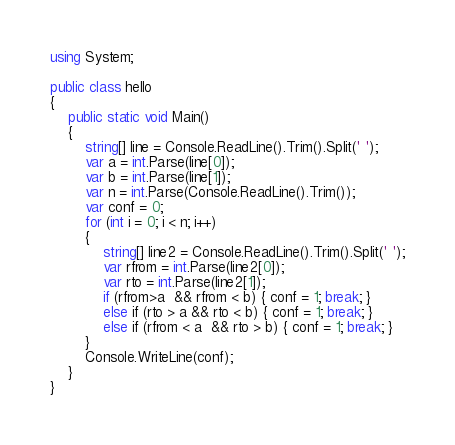<code> <loc_0><loc_0><loc_500><loc_500><_C#_>using System;

public class hello
{
    public static void Main()
    {
        string[] line = Console.ReadLine().Trim().Split(' ');
        var a = int.Parse(line[0]);
        var b = int.Parse(line[1]);
        var n = int.Parse(Console.ReadLine().Trim());
        var conf = 0;
        for (int i = 0; i < n; i++)
        {
            string[] line2 = Console.ReadLine().Trim().Split(' ');
            var rfrom = int.Parse(line2[0]);
            var rto = int.Parse(line2[1]);
            if (rfrom>a  && rfrom < b) { conf = 1; break; }
            else if (rto > a && rto < b) { conf = 1; break; }
            else if (rfrom < a  && rto > b) { conf = 1; break; }
        }
        Console.WriteLine(conf);
    }
}</code> 